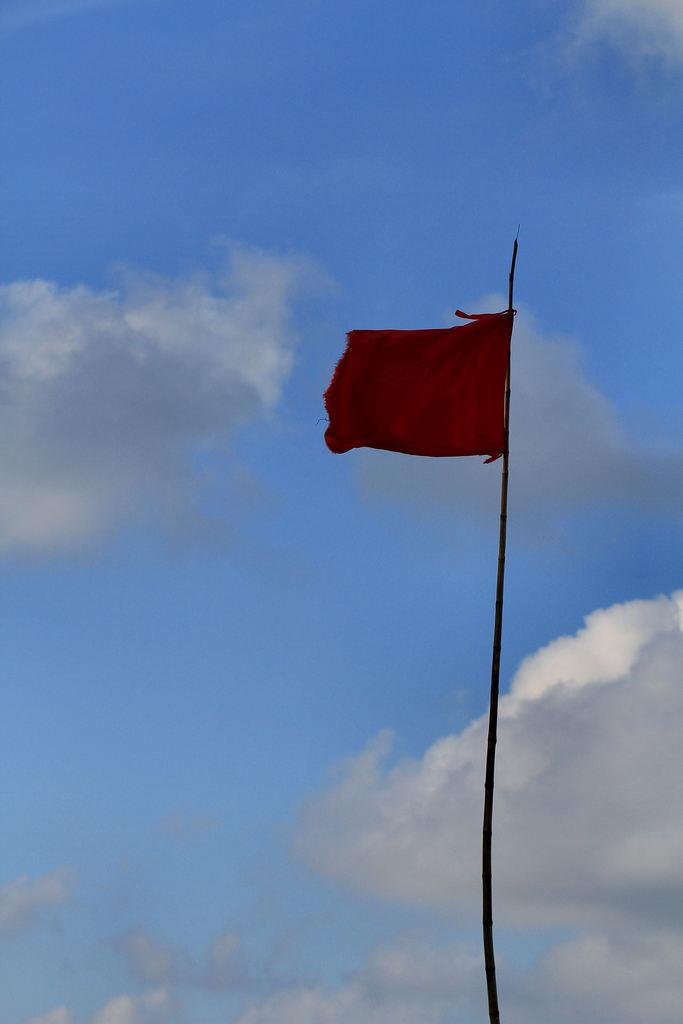What is the main object in the image? There is a flag in the image. What can be seen in the background of the image? The sky is visible in the background of the image. What is the condition of the sky in the image? Clouds are present in the sky. What type of medical advice is the flag giving in the image? The flag is not a doctor and cannot give medical advice; it is simply a flag. 